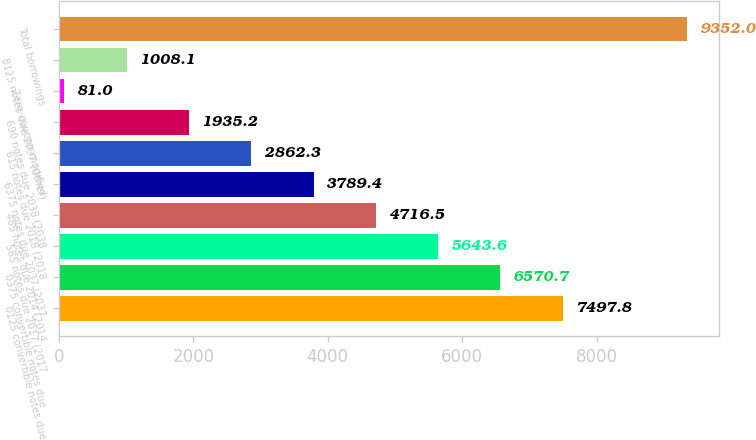Convert chart. <chart><loc_0><loc_0><loc_500><loc_500><bar_chart><fcel>0125 convertible notes due<fcel>0375 convertible notes due<fcel>585 notes due 2017 (2017<fcel>485 notes due 2014 (2014<fcel>6375 notes due 2037 (2037<fcel>615 notes due 2018 (2018<fcel>690 notes due 2038 (2038<fcel>Zero-coupon modified<fcel>8125 notes due 2097 (Other)<fcel>Total borrowings<nl><fcel>7497.8<fcel>6570.7<fcel>5643.6<fcel>4716.5<fcel>3789.4<fcel>2862.3<fcel>1935.2<fcel>81<fcel>1008.1<fcel>9352<nl></chart> 